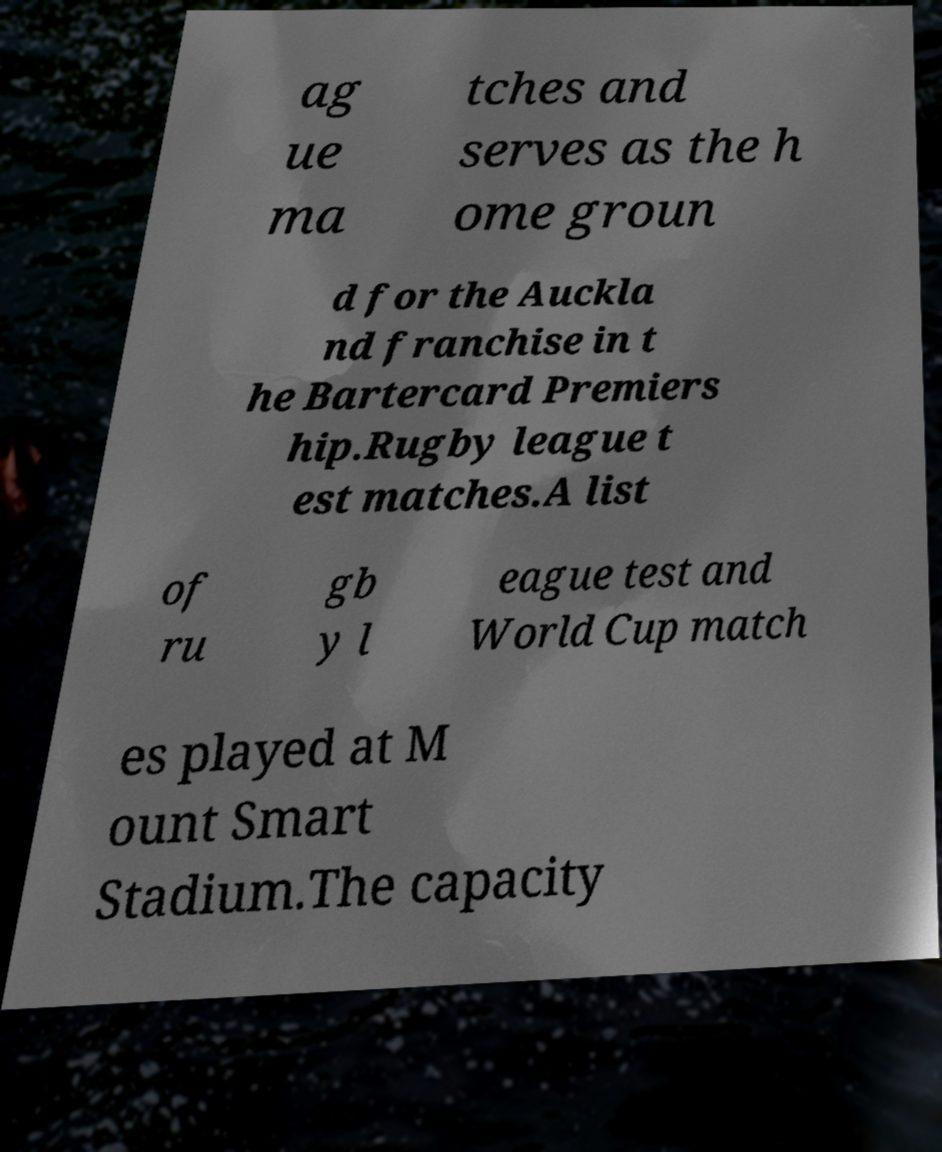Can you accurately transcribe the text from the provided image for me? ag ue ma tches and serves as the h ome groun d for the Auckla nd franchise in t he Bartercard Premiers hip.Rugby league t est matches.A list of ru gb y l eague test and World Cup match es played at M ount Smart Stadium.The capacity 